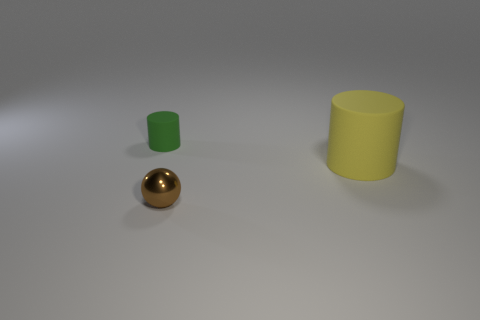How many other things are there of the same color as the large rubber object?
Give a very brief answer. 0. What material is the big thing?
Provide a succinct answer. Rubber. The object that is both left of the large yellow rubber cylinder and to the right of the small cylinder is made of what material?
Provide a succinct answer. Metal. What number of things are rubber cylinders that are behind the big cylinder or yellow rubber things?
Your answer should be compact. 2. Does the tiny sphere have the same color as the small rubber cylinder?
Keep it short and to the point. No. Is there a purple cylinder of the same size as the green cylinder?
Your answer should be very brief. No. What number of objects are to the left of the yellow object and behind the small shiny ball?
Keep it short and to the point. 1. What number of large yellow rubber cylinders are on the left side of the tiny ball?
Ensure brevity in your answer.  0. Are there any large rubber things that have the same shape as the tiny brown thing?
Give a very brief answer. No. There is a large yellow matte thing; is it the same shape as the tiny object on the left side of the metal object?
Ensure brevity in your answer.  Yes. 